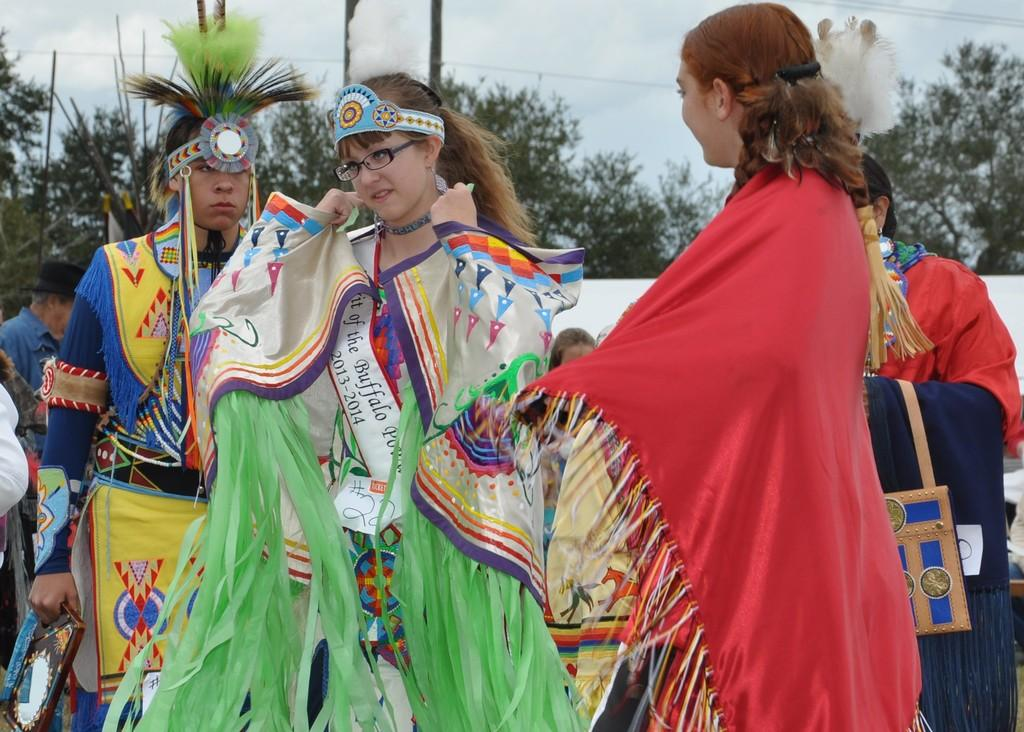What is the main subject of the image? The main subject of the image is a group of people. How are the people dressed in the image? The people are wearing different kinds of dresses in the image. What can be seen in the background of the image? There are trees, poles, and electric wires in the background of the image. What is visible at the top of the image? The sky is visible at the top of the image. What type of drum can be heard during the meeting in the image? There is no drum or meeting present in the image; it features a group of people with different dresses in front of a background with trees, poles, and electric wires. Where is the sink located in the image? There is no sink present in the image. 